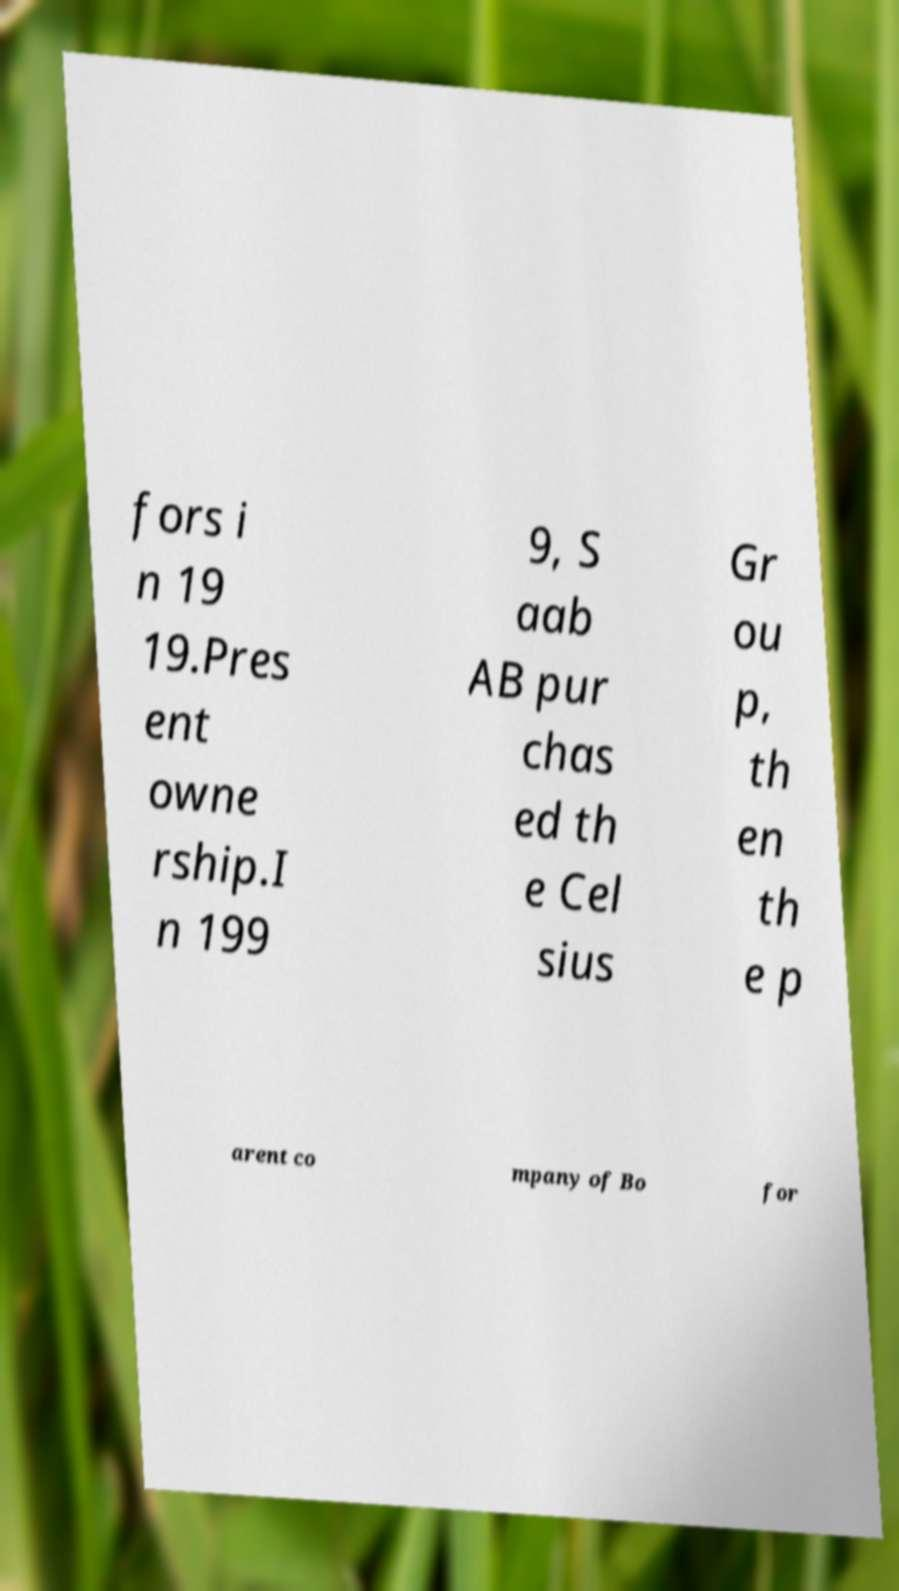There's text embedded in this image that I need extracted. Can you transcribe it verbatim? fors i n 19 19.Pres ent owne rship.I n 199 9, S aab AB pur chas ed th e Cel sius Gr ou p, th en th e p arent co mpany of Bo for 